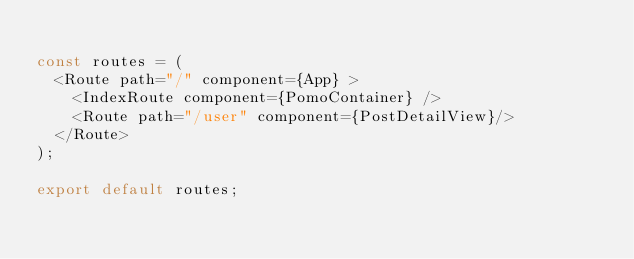Convert code to text. <code><loc_0><loc_0><loc_500><loc_500><_JavaScript_>
const routes = (
  <Route path="/" component={App} >
    <IndexRoute component={PomoContainer} />
    <Route path="/user" component={PostDetailView}/>
  </Route>
);

export default routes;
</code> 